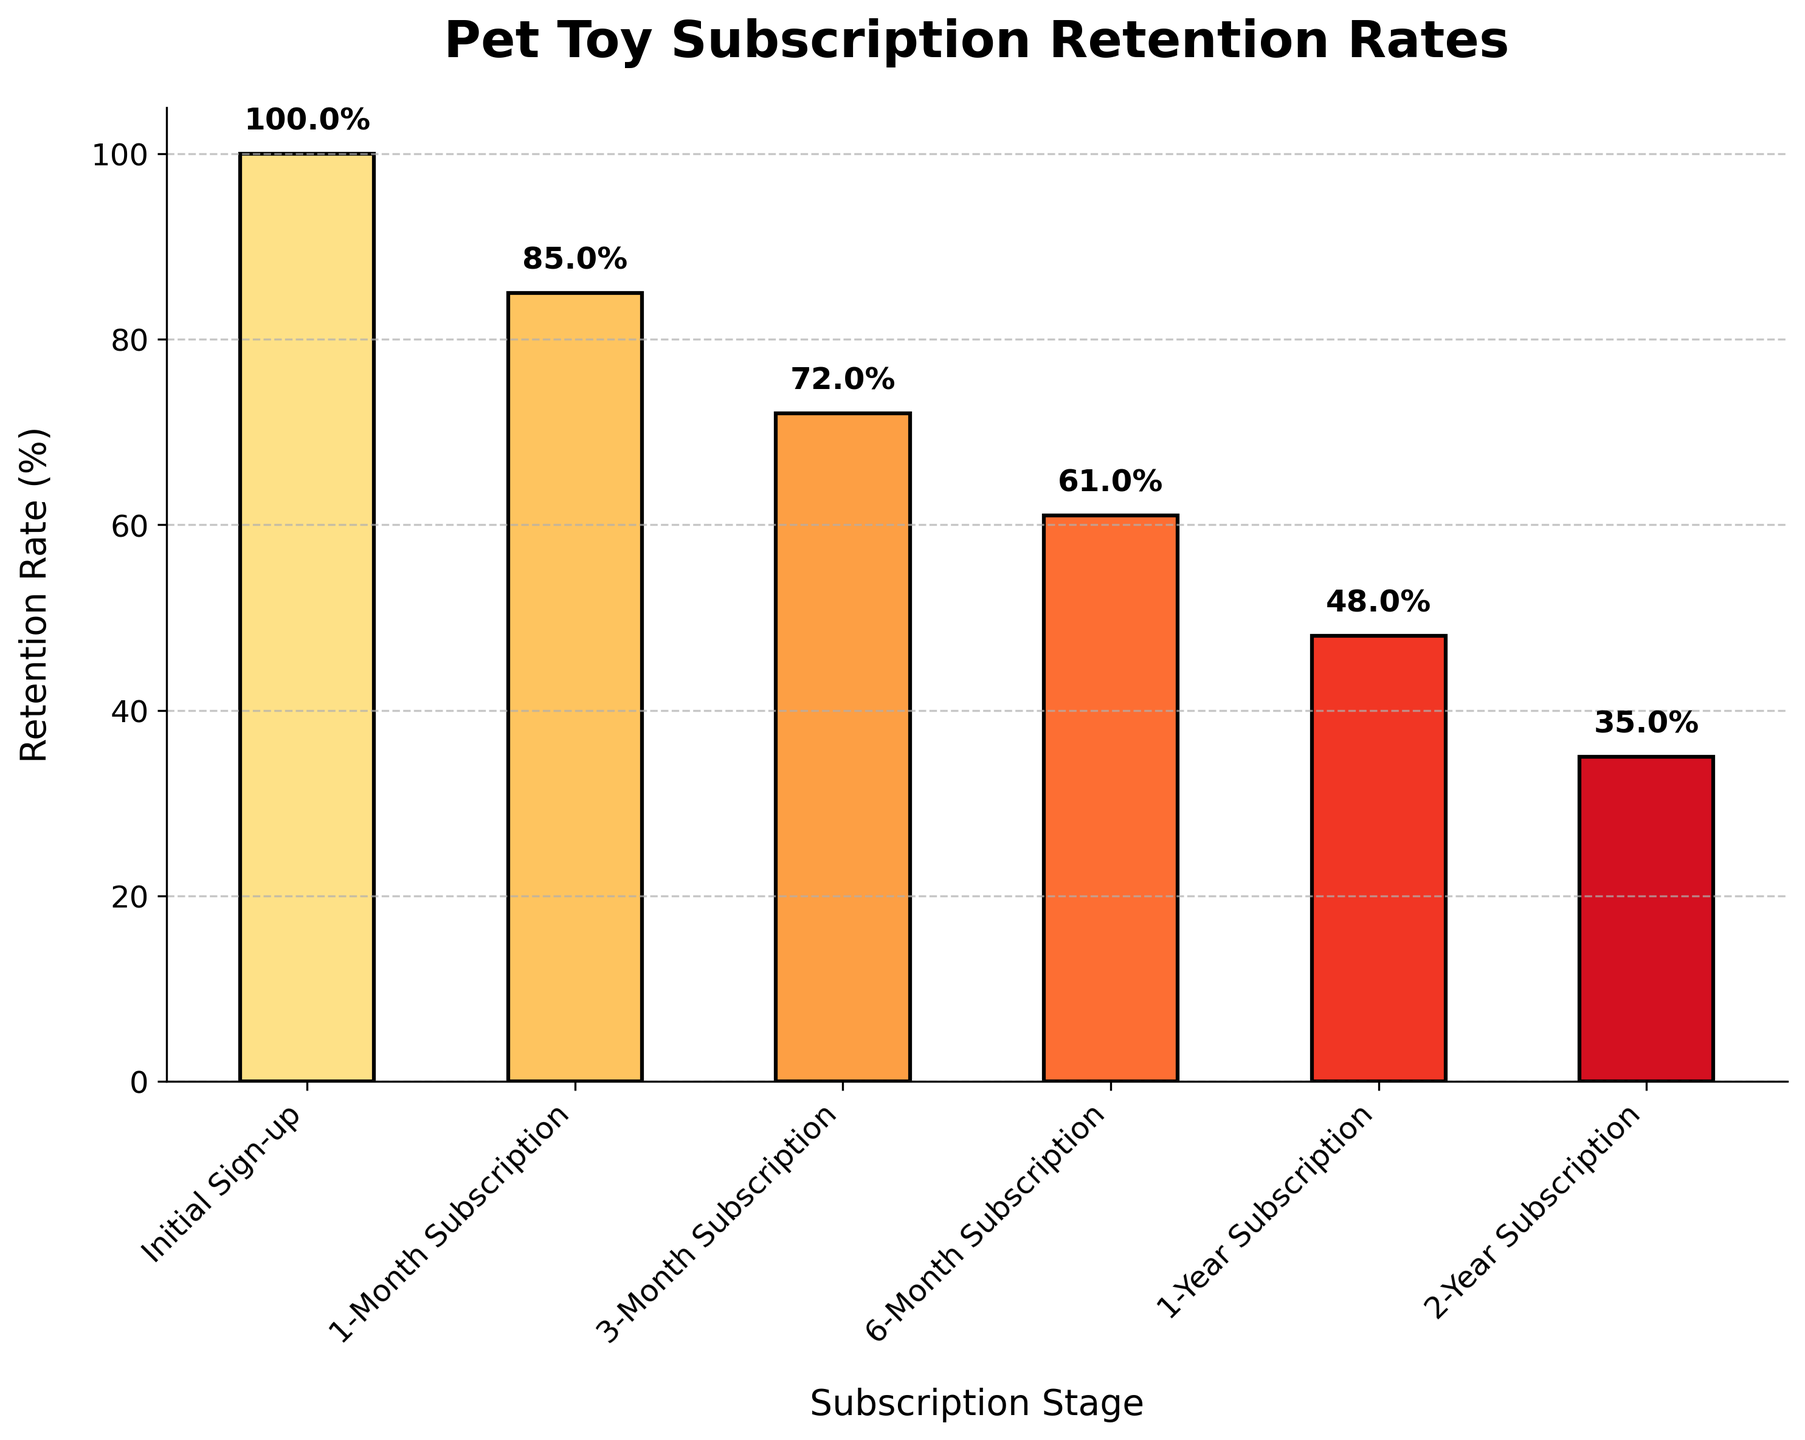What is the title of the plot? The title of the plot can be seen at the top of the chart. It is displayed in bold and is meant to summarize the focus of the data presented.
Answer: Pet Toy Subscription Retention Rates How many subscription stages are shown in the plot? To determine the number of subscription stages, count the distinct bars in the chart, each labeled with a stage name on the x-axis.
Answer: Six What is the retention rate for the 3-month subscription stage? The retention rate at each stage is displayed above each bar. Locate the 3-Month Subscription label and the corresponding bar and note the value written above it.
Answer: 72% Which subscription stage has the lowest retention rate? Compare the lengths of all the bars, identifying the shortest one. The shortest bar corresponds to the lowest retention rate.
Answer: 2-Year Subscription How does the retention rate change from the Initial Sign-up to the 1-Year Subscription? Subtract the retention rate at the 1-Year Subscription stage from the Initial Sign-up rate. These rates can be read from the values displayed above the respective bars.
Answer: 100% - 48% = 52% decrease What is the average retention rate across all stages? To find the average, add all the retention rates and divide by the number of stages. Sum the values (100% + 85% + 72% + 61% + 48% + 35%) and then divide by 6.
Answer: (100 + 85 + 72 + 61 + 48 + 35) / 6 = 66.83% By how much does the retention rate drop from the 1-Month Subscription to the 6-Month Subscription? Subtract the retention rate at 6-Month Subscription from the rate at 1-Month Subscription. These rates are displayed above the respective bars.
Answer: 85% - 61% = 24% Between which two consecutive stages is the largest drop in retention rate observed? Calculate the drop between each pair of consecutive stages by subtracting the later stage’s rate from the earlier stage’s rate, then identify the largest difference. Initial Sign-up to 1-Month: 15%, 1-Month to 3-Month: 13%, 3-Month to 6-Month: 11%, 6-Month to 1-Year: 13%, 1-Year to 2-Year: 13%.
Answer: Initial Sign-up to 1-Month Subscription What is the median retention rate among all the stages? List the values in numerical order and find the middle value. For an even number of values, calculate the average of the two middle numbers. Ordered rates: 35, 48, 61, 72, 85, 100. Median is the average of 61 and 72.
Answer: (61 + 72) / 2 = 66.5% What percentage of customers remain subscribed after one year? Locate the 1-Year Subscription bar and read the retention rate displayed above it.
Answer: 48% 